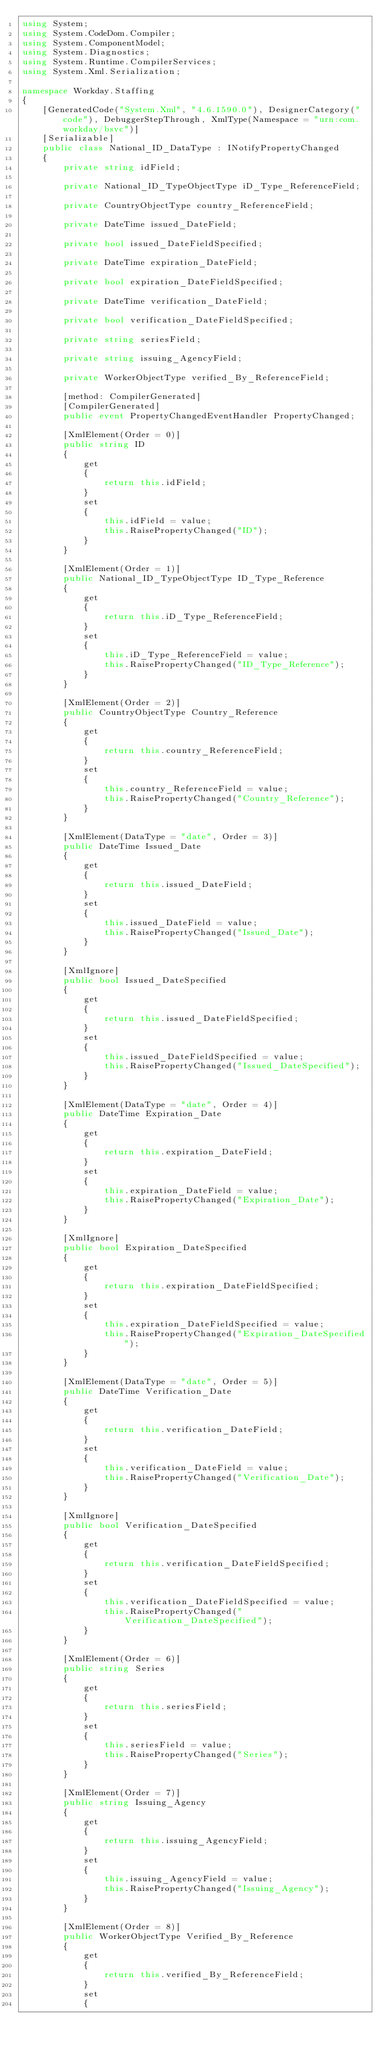Convert code to text. <code><loc_0><loc_0><loc_500><loc_500><_C#_>using System;
using System.CodeDom.Compiler;
using System.ComponentModel;
using System.Diagnostics;
using System.Runtime.CompilerServices;
using System.Xml.Serialization;

namespace Workday.Staffing
{
	[GeneratedCode("System.Xml", "4.6.1590.0"), DesignerCategory("code"), DebuggerStepThrough, XmlType(Namespace = "urn:com.workday/bsvc")]
	[Serializable]
	public class National_ID_DataType : INotifyPropertyChanged
	{
		private string idField;

		private National_ID_TypeObjectType iD_Type_ReferenceField;

		private CountryObjectType country_ReferenceField;

		private DateTime issued_DateField;

		private bool issued_DateFieldSpecified;

		private DateTime expiration_DateField;

		private bool expiration_DateFieldSpecified;

		private DateTime verification_DateField;

		private bool verification_DateFieldSpecified;

		private string seriesField;

		private string issuing_AgencyField;

		private WorkerObjectType verified_By_ReferenceField;

		[method: CompilerGenerated]
		[CompilerGenerated]
		public event PropertyChangedEventHandler PropertyChanged;

		[XmlElement(Order = 0)]
		public string ID
		{
			get
			{
				return this.idField;
			}
			set
			{
				this.idField = value;
				this.RaisePropertyChanged("ID");
			}
		}

		[XmlElement(Order = 1)]
		public National_ID_TypeObjectType ID_Type_Reference
		{
			get
			{
				return this.iD_Type_ReferenceField;
			}
			set
			{
				this.iD_Type_ReferenceField = value;
				this.RaisePropertyChanged("ID_Type_Reference");
			}
		}

		[XmlElement(Order = 2)]
		public CountryObjectType Country_Reference
		{
			get
			{
				return this.country_ReferenceField;
			}
			set
			{
				this.country_ReferenceField = value;
				this.RaisePropertyChanged("Country_Reference");
			}
		}

		[XmlElement(DataType = "date", Order = 3)]
		public DateTime Issued_Date
		{
			get
			{
				return this.issued_DateField;
			}
			set
			{
				this.issued_DateField = value;
				this.RaisePropertyChanged("Issued_Date");
			}
		}

		[XmlIgnore]
		public bool Issued_DateSpecified
		{
			get
			{
				return this.issued_DateFieldSpecified;
			}
			set
			{
				this.issued_DateFieldSpecified = value;
				this.RaisePropertyChanged("Issued_DateSpecified");
			}
		}

		[XmlElement(DataType = "date", Order = 4)]
		public DateTime Expiration_Date
		{
			get
			{
				return this.expiration_DateField;
			}
			set
			{
				this.expiration_DateField = value;
				this.RaisePropertyChanged("Expiration_Date");
			}
		}

		[XmlIgnore]
		public bool Expiration_DateSpecified
		{
			get
			{
				return this.expiration_DateFieldSpecified;
			}
			set
			{
				this.expiration_DateFieldSpecified = value;
				this.RaisePropertyChanged("Expiration_DateSpecified");
			}
		}

		[XmlElement(DataType = "date", Order = 5)]
		public DateTime Verification_Date
		{
			get
			{
				return this.verification_DateField;
			}
			set
			{
				this.verification_DateField = value;
				this.RaisePropertyChanged("Verification_Date");
			}
		}

		[XmlIgnore]
		public bool Verification_DateSpecified
		{
			get
			{
				return this.verification_DateFieldSpecified;
			}
			set
			{
				this.verification_DateFieldSpecified = value;
				this.RaisePropertyChanged("Verification_DateSpecified");
			}
		}

		[XmlElement(Order = 6)]
		public string Series
		{
			get
			{
				return this.seriesField;
			}
			set
			{
				this.seriesField = value;
				this.RaisePropertyChanged("Series");
			}
		}

		[XmlElement(Order = 7)]
		public string Issuing_Agency
		{
			get
			{
				return this.issuing_AgencyField;
			}
			set
			{
				this.issuing_AgencyField = value;
				this.RaisePropertyChanged("Issuing_Agency");
			}
		}

		[XmlElement(Order = 8)]
		public WorkerObjectType Verified_By_Reference
		{
			get
			{
				return this.verified_By_ReferenceField;
			}
			set
			{</code> 